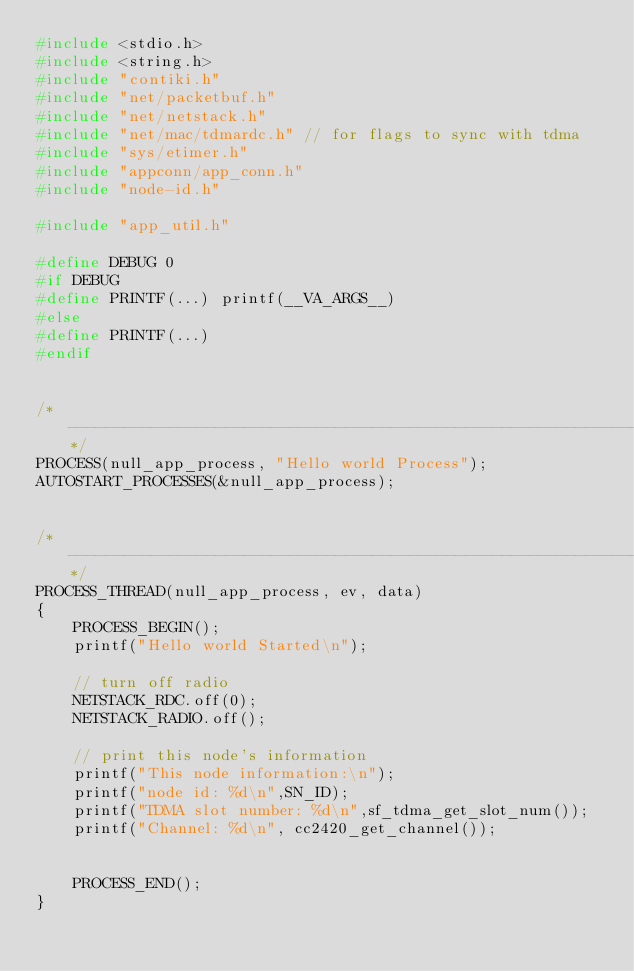<code> <loc_0><loc_0><loc_500><loc_500><_C_>#include <stdio.h>
#include <string.h>
#include "contiki.h"
#include "net/packetbuf.h"
#include "net/netstack.h"
#include "net/mac/tdmardc.h" // for flags to sync with tdma 
#include "sys/etimer.h"
#include "appconn/app_conn.h"
#include "node-id.h"

#include "app_util.h"

#define DEBUG 0
#if DEBUG
#define PRINTF(...) printf(__VA_ARGS__)
#else
#define PRINTF(...)
#endif


/*---------------------------------------------------------------*/
PROCESS(null_app_process, "Hello world Process");
AUTOSTART_PROCESSES(&null_app_process);


/*---------------------------------------------------------------*/
PROCESS_THREAD(null_app_process, ev, data)
{
	PROCESS_BEGIN();
	printf("Hello world Started\n");

	// turn off radio
	NETSTACK_RDC.off(0);
	NETSTACK_RADIO.off();

	// print this node's information
	printf("This node information:\n");
	printf("node id: %d\n",SN_ID);
	printf("TDMA slot number: %d\n",sf_tdma_get_slot_num());
	printf("Channel: %d\n", cc2420_get_channel());

	
	PROCESS_END();
}

</code> 